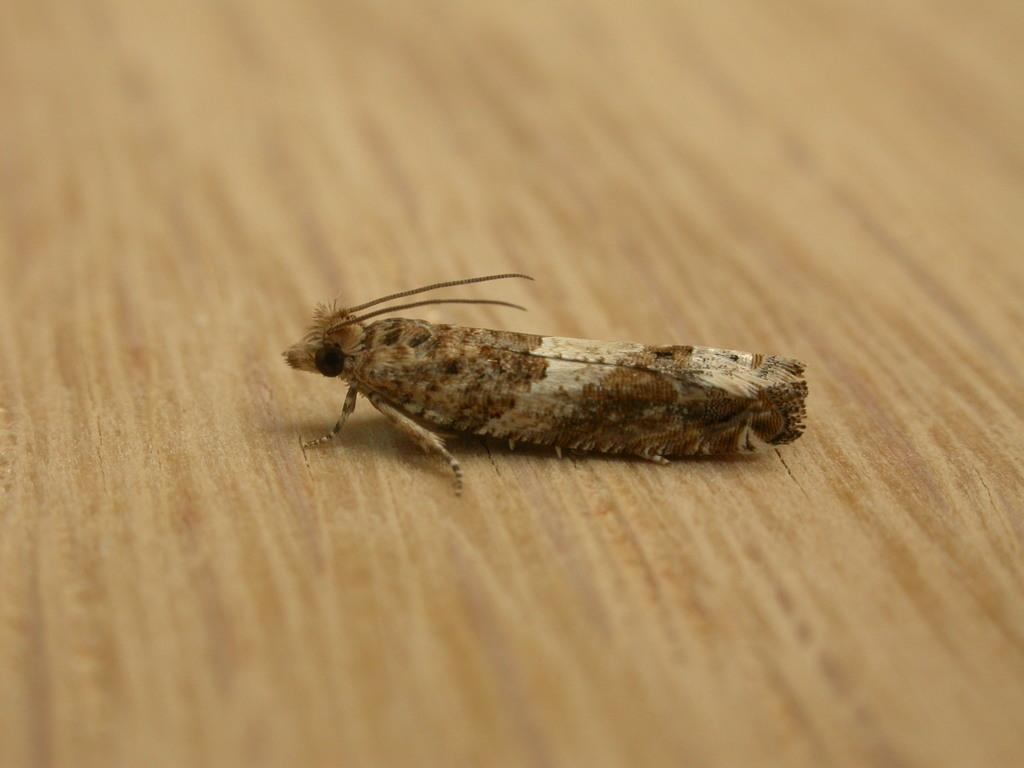What type of creature can be seen in the image? There is an insect in the image. Where is the insect located? The insect is on a wooden floor. How many cars are parked in the office in the image? There is no office or cars present in the image; it features an insect on a wooden floor. 